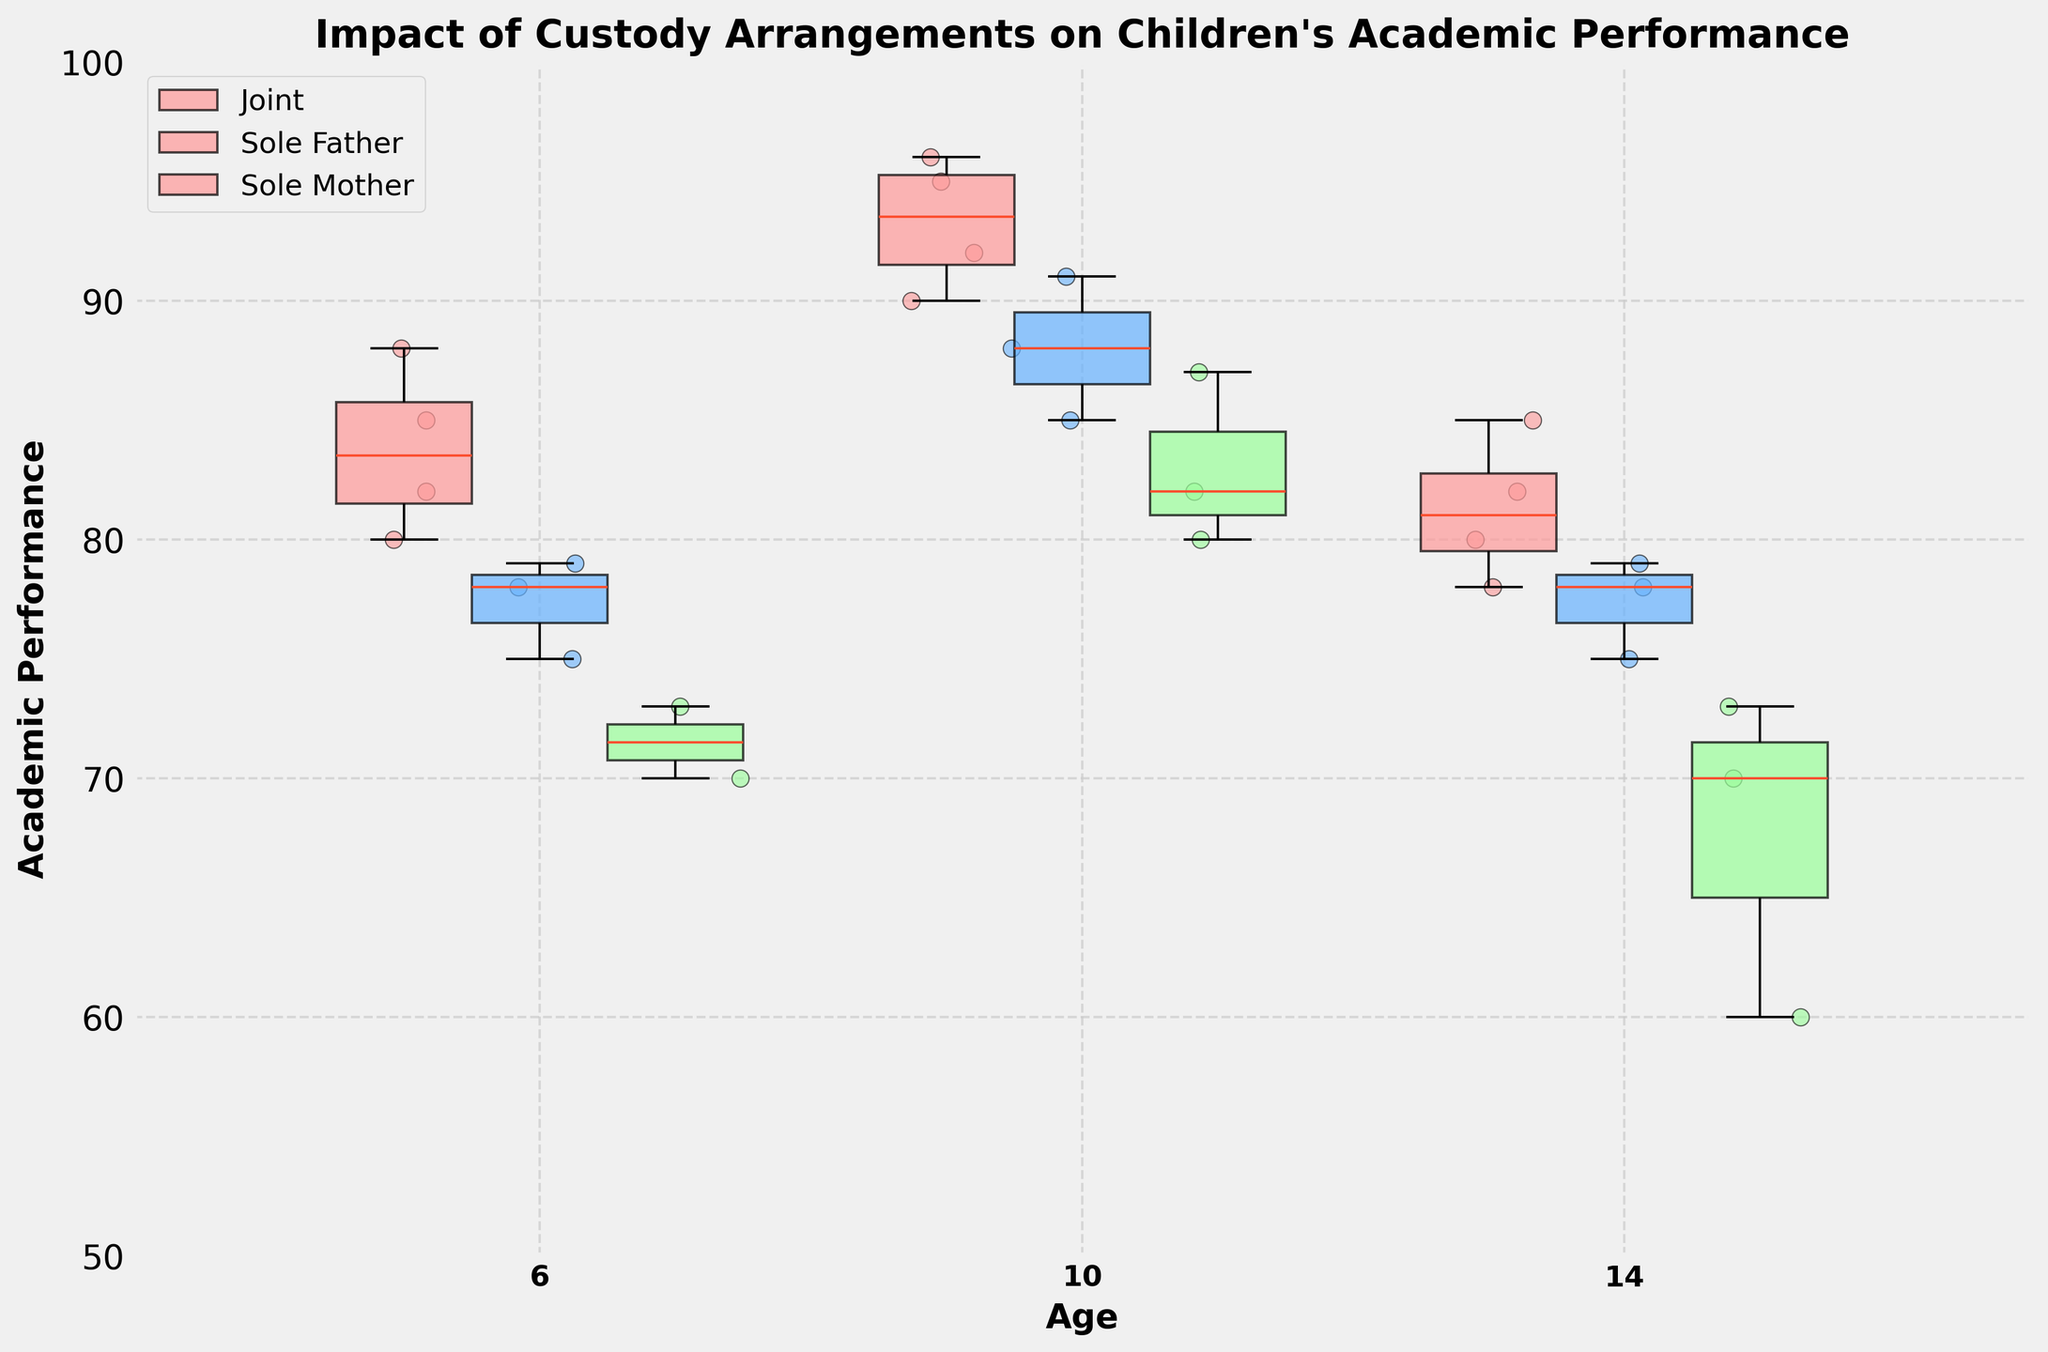How many different age groups are shown in the figure? The x-axis labels for the Box Plot show the different age groups. There are three age groups displayed.
Answer: 3 What is the custody arrangement shown in red? Each box in the Box Plot is colored differently. Red boxes indicate "Joint" custody arrangement.
Answer: Joint Which custody arrangement has the highest median academic performance at age 10? In the Box Plot, locate the boxes for age 10. The box with the highest horizontal line (median) corresponds to the "Joint" custody arrangement.
Answer: Joint For age 6, which custody arrangement has the widest range of academic performance? The range is the distance between the bottom and top of each box (interquartile range) or including whiskers for each custody type at age 6. The "Sole Mother" custody arrangement shows the widest range.
Answer: Sole Mother What is the maximum academic performance score for children aged 14 with "Sole Father" custody? The maximum value is represented by the top end of the whisker for the "Sole Father" custody box at age 14. The top whisker reaches 79.
Answer: 79 In which age group does "Joint" custody arrangement show the highest variance in academic performance? The variance can be visually assessed by the spread and length of the boxes and whiskers representing "Joint" custody for each age group. The highest variance in "Joint" custody is seen at age 6 as the box and whiskers are the most spread out.
Answer: 6 How does the median academic performance for "Joint" custody arrangement compare between age 6 and age 10? The horizontal lines inside the "Joint" custody boxes indicate the medians. Comparing them shows that the median academic performance at age 10 is higher than at age 6.
Answer: Higher at age 10 Is there a noticeable outlier in academic performance for any age group under "Sole Mother"? Outliers are usually indicated by individual points outside the whiskers in a Box Plot. There is a noticeable outlier in the "Sole Mother" custody arrangement for age 14.
Answer: Yes Between "Sole Father" and "Sole Mother" custody at age 10, which has better academic performance? Compare the median lines (horizontal lines inside the boxes) of "Sole Father" and "Sole Mother" at age 10. The "Sole Father" median is higher.
Answer: Sole Father Which custody arrangement shows the most consistent academic performance across all ages? Consistency can be assessed by looking for the smallest interquartile ranges and short whiskers across all age groups. The "Joint" custody arrangement shows the most consistent academic performance.
Answer: Joint 